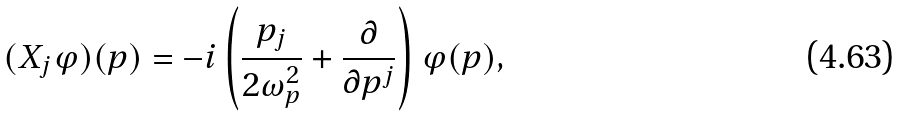Convert formula to latex. <formula><loc_0><loc_0><loc_500><loc_500>( X _ { j } \varphi ) ( p ) = - i \left ( \frac { p _ { j } } { 2 \omega _ { p } ^ { 2 } } + \frac { \partial } { \partial p ^ { j } } \right ) \varphi ( p ) ,</formula> 